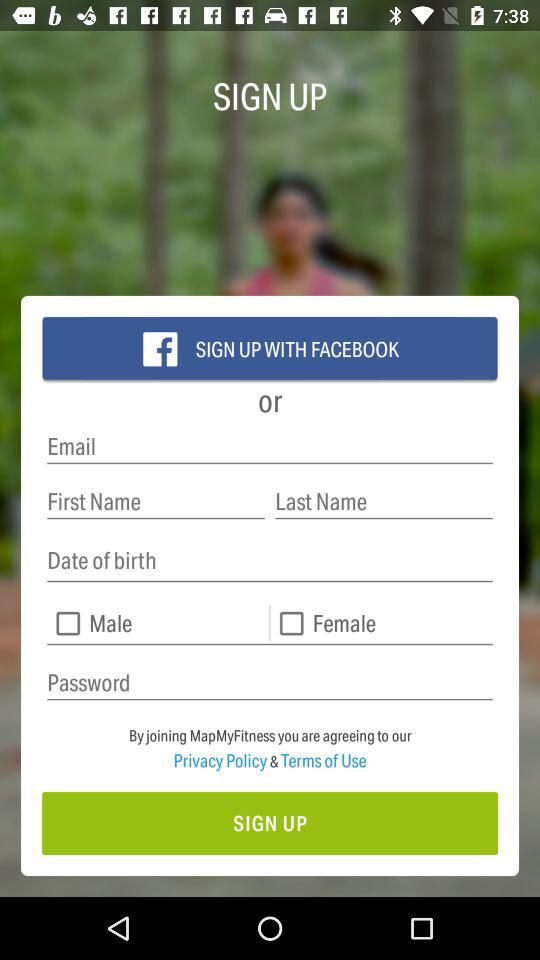What is the status of "Male"? The status is "off". 